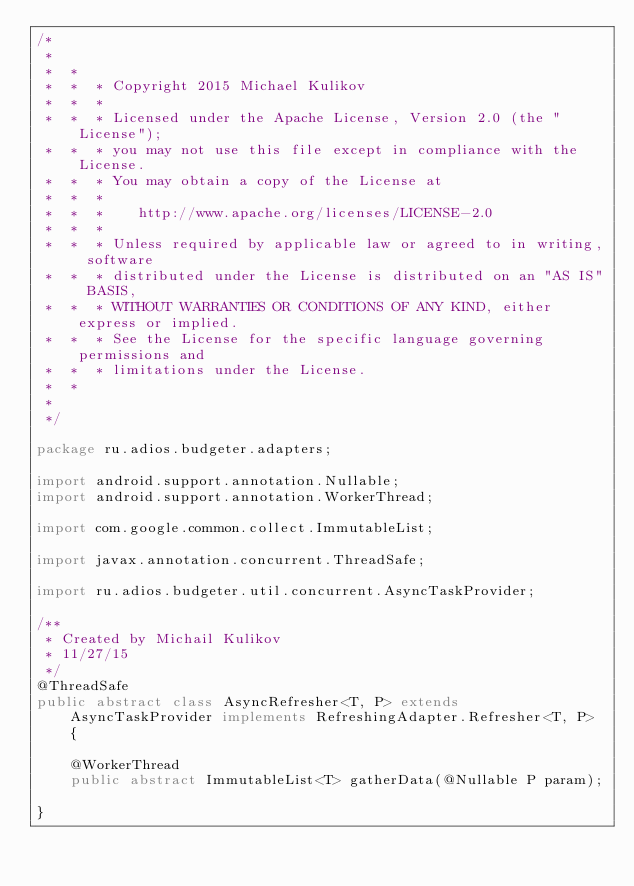<code> <loc_0><loc_0><loc_500><loc_500><_Java_>/*
 *
 *  *
 *  *  * Copyright 2015 Michael Kulikov
 *  *  *
 *  *  * Licensed under the Apache License, Version 2.0 (the "License");
 *  *  * you may not use this file except in compliance with the License.
 *  *  * You may obtain a copy of the License at
 *  *  *
 *  *  *    http://www.apache.org/licenses/LICENSE-2.0
 *  *  *
 *  *  * Unless required by applicable law or agreed to in writing, software
 *  *  * distributed under the License is distributed on an "AS IS" BASIS,
 *  *  * WITHOUT WARRANTIES OR CONDITIONS OF ANY KIND, either express or implied.
 *  *  * See the License for the specific language governing permissions and
 *  *  * limitations under the License.
 *  *
 *
 */

package ru.adios.budgeter.adapters;

import android.support.annotation.Nullable;
import android.support.annotation.WorkerThread;

import com.google.common.collect.ImmutableList;

import javax.annotation.concurrent.ThreadSafe;

import ru.adios.budgeter.util.concurrent.AsyncTaskProvider;

/**
 * Created by Michail Kulikov
 * 11/27/15
 */
@ThreadSafe
public abstract class AsyncRefresher<T, P> extends AsyncTaskProvider implements RefreshingAdapter.Refresher<T, P> {

    @WorkerThread
    public abstract ImmutableList<T> gatherData(@Nullable P param);

}
</code> 